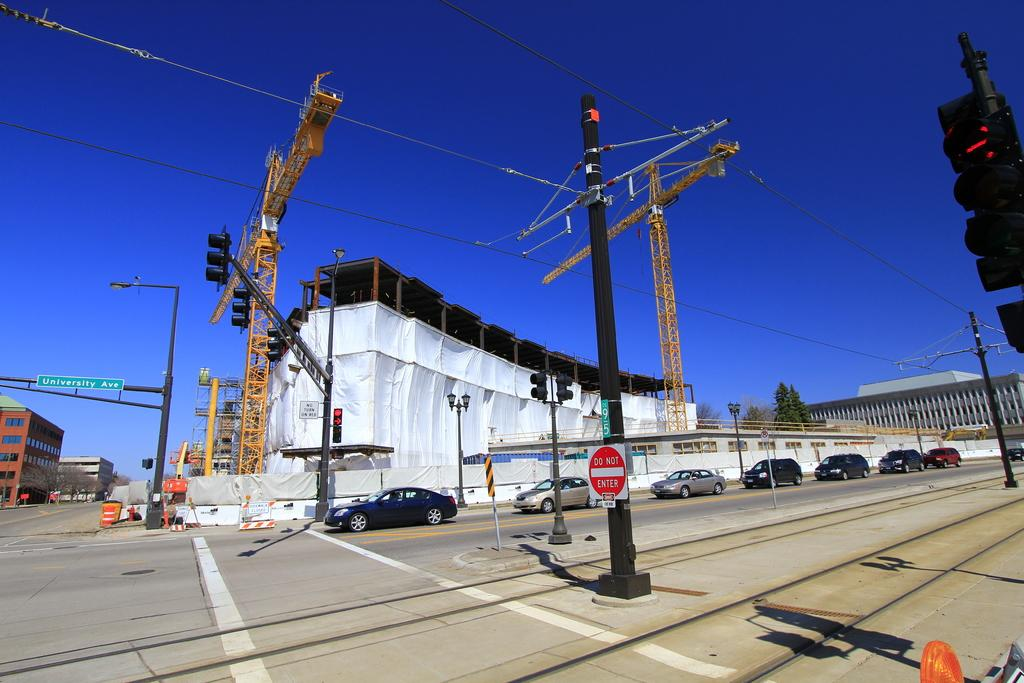<image>
Share a concise interpretation of the image provided. building construction at intersection of roads, one is university avenue 